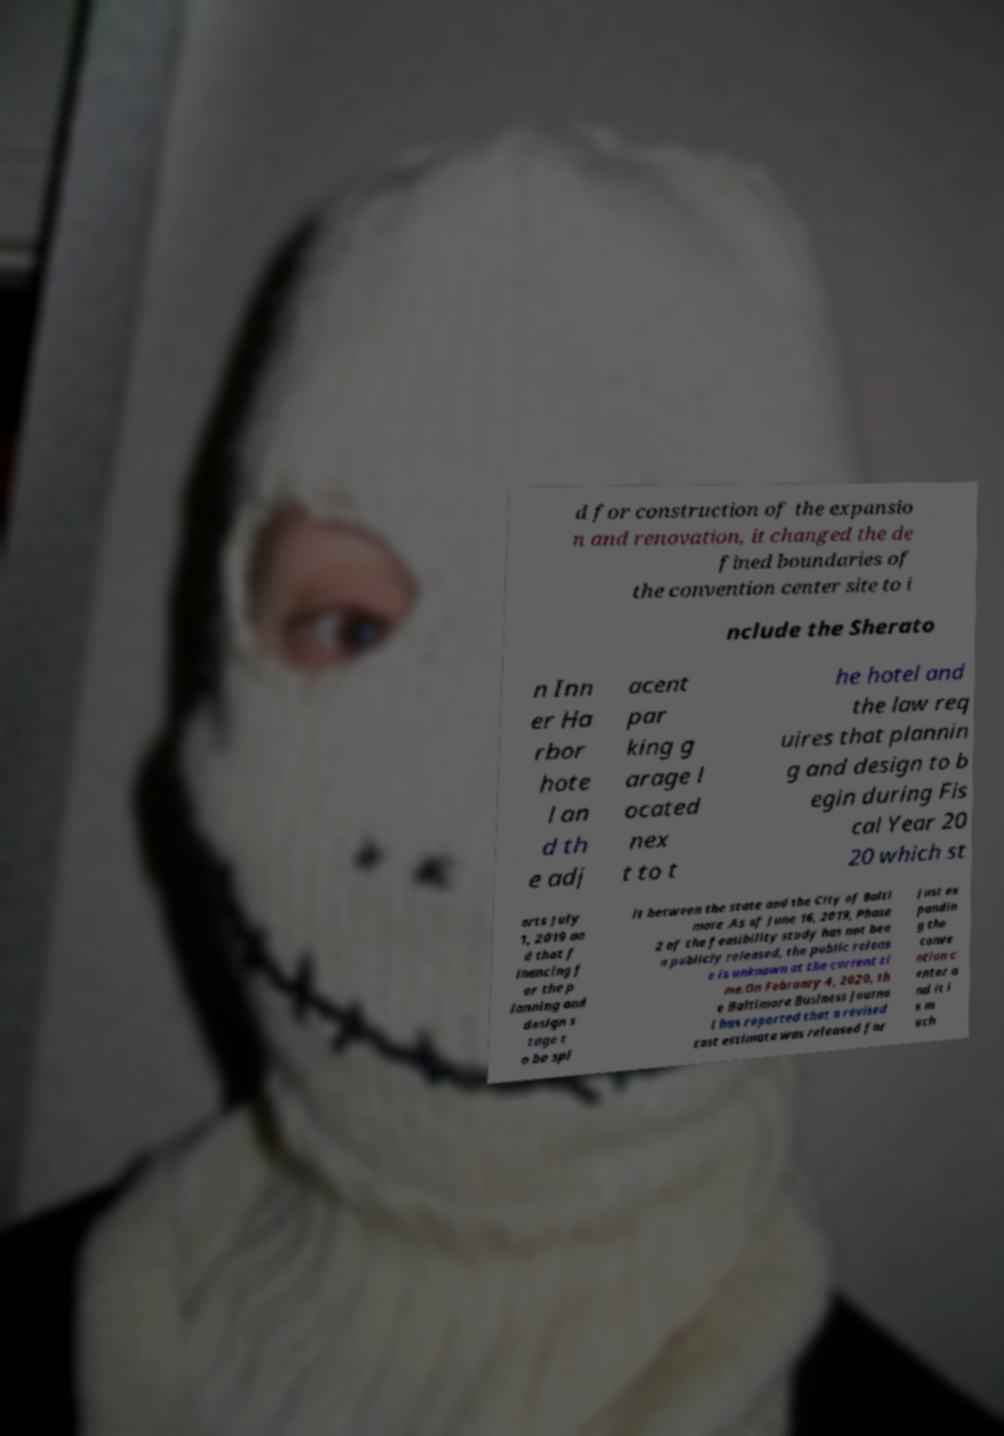Can you read and provide the text displayed in the image?This photo seems to have some interesting text. Can you extract and type it out for me? d for construction of the expansio n and renovation, it changed the de fined boundaries of the convention center site to i nclude the Sherato n Inn er Ha rbor hote l an d th e adj acent par king g arage l ocated nex t to t he hotel and the law req uires that plannin g and design to b egin during Fis cal Year 20 20 which st arts July 1, 2019 an d that f inancing f or the p lanning and design s tage t o be spl it between the state and the City of Balti more .As of June 16, 2019, Phase 2 of the feasibility study has not bee n publicly released, the public releas e is unknown at the current ti me.On February 4, 2020, th e Baltimore Business Journa l has reported that a revised cost estimate was released for just ex pandin g the conve ntion c enter a nd it i s m uch 